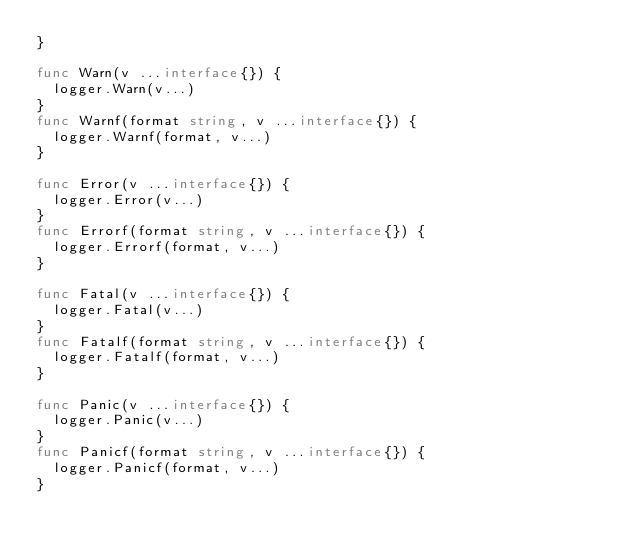Convert code to text. <code><loc_0><loc_0><loc_500><loc_500><_Go_>}

func Warn(v ...interface{}) {
	logger.Warn(v...)
}
func Warnf(format string, v ...interface{}) {
	logger.Warnf(format, v...)
}

func Error(v ...interface{}) {
	logger.Error(v...)
}
func Errorf(format string, v ...interface{}) {
	logger.Errorf(format, v...)
}

func Fatal(v ...interface{}) {
	logger.Fatal(v...)
}
func Fatalf(format string, v ...interface{}) {
	logger.Fatalf(format, v...)
}

func Panic(v ...interface{}) {
	logger.Panic(v...)
}
func Panicf(format string, v ...interface{}) {
	logger.Panicf(format, v...)
}
</code> 